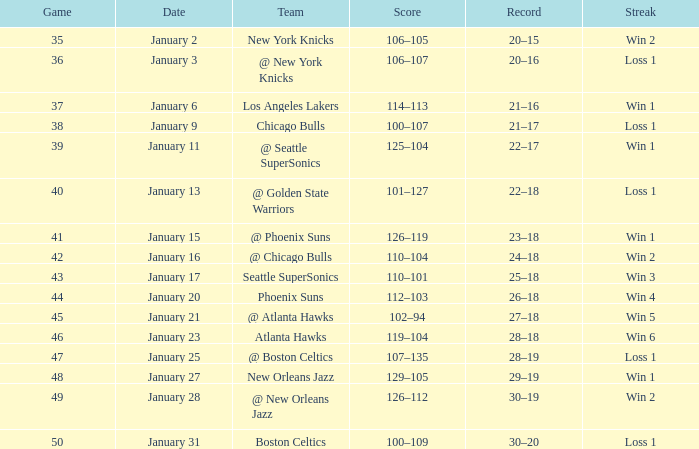What is the Streak in the game with a Record of 20–16? Loss 1. 